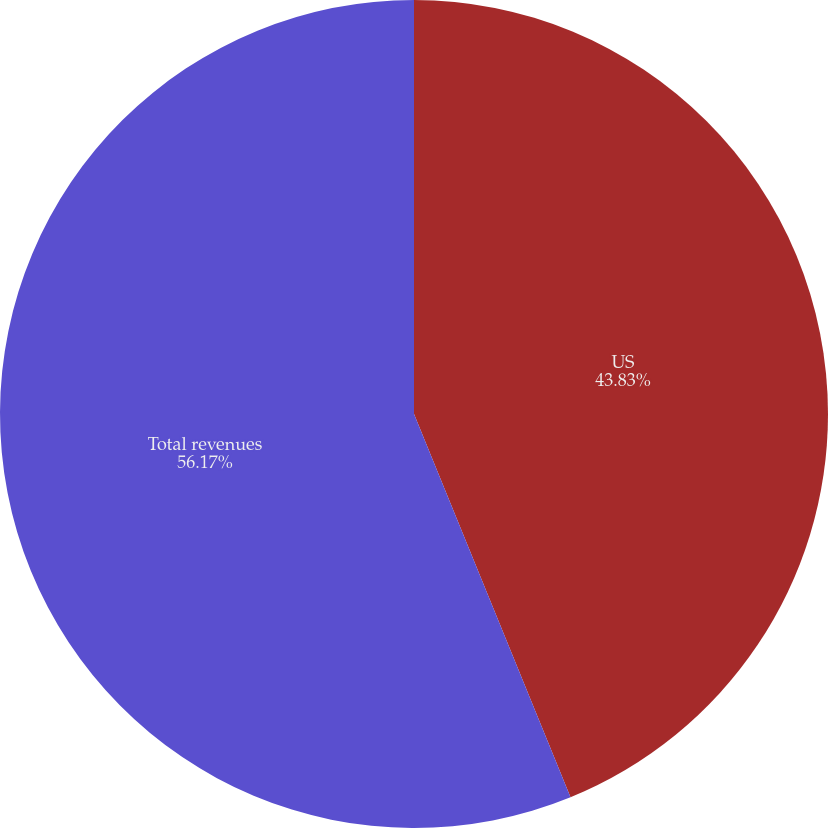Convert chart to OTSL. <chart><loc_0><loc_0><loc_500><loc_500><pie_chart><fcel>US<fcel>Total revenues<nl><fcel>43.83%<fcel>56.17%<nl></chart> 